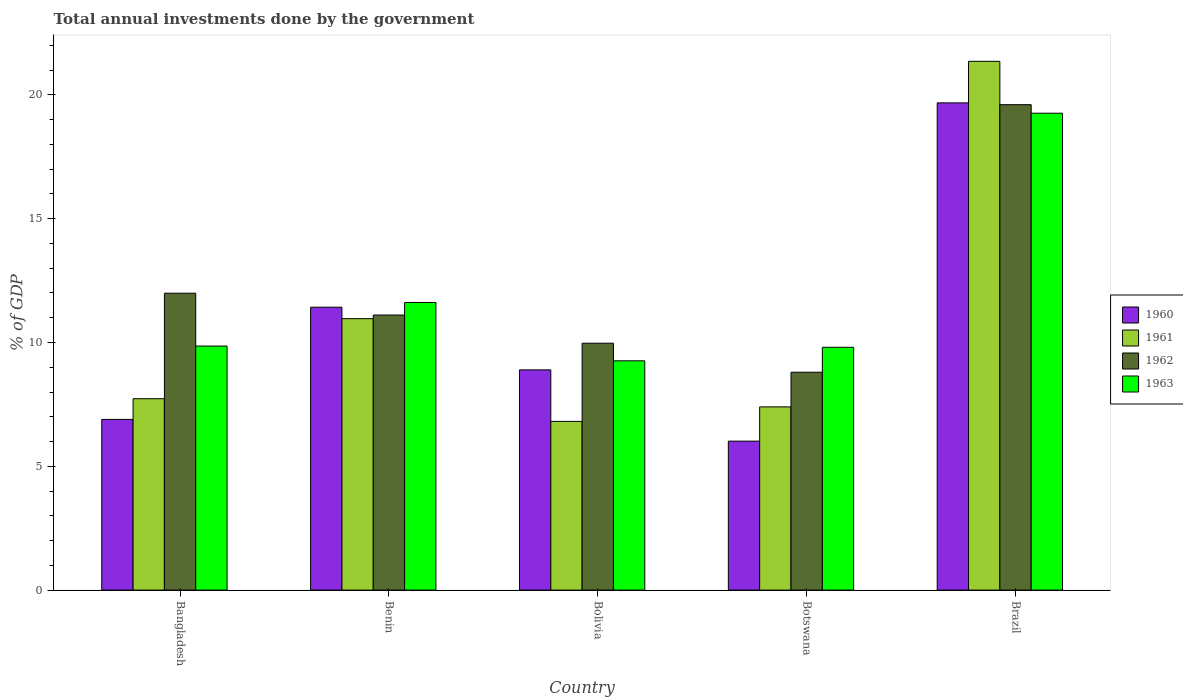How many different coloured bars are there?
Ensure brevity in your answer.  4. How many groups of bars are there?
Ensure brevity in your answer.  5. Are the number of bars on each tick of the X-axis equal?
Provide a succinct answer. Yes. How many bars are there on the 5th tick from the right?
Provide a succinct answer. 4. What is the label of the 5th group of bars from the left?
Your answer should be very brief. Brazil. What is the total annual investments done by the government in 1962 in Botswana?
Provide a succinct answer. 8.8. Across all countries, what is the maximum total annual investments done by the government in 1963?
Offer a very short reply. 19.26. Across all countries, what is the minimum total annual investments done by the government in 1961?
Keep it short and to the point. 6.81. In which country was the total annual investments done by the government in 1961 maximum?
Offer a terse response. Brazil. In which country was the total annual investments done by the government in 1962 minimum?
Your answer should be compact. Botswana. What is the total total annual investments done by the government in 1960 in the graph?
Offer a very short reply. 52.91. What is the difference between the total annual investments done by the government in 1960 in Bangladesh and that in Botswana?
Your answer should be compact. 0.88. What is the difference between the total annual investments done by the government in 1962 in Benin and the total annual investments done by the government in 1960 in Botswana?
Ensure brevity in your answer.  5.09. What is the average total annual investments done by the government in 1960 per country?
Provide a short and direct response. 10.58. What is the difference between the total annual investments done by the government of/in 1962 and total annual investments done by the government of/in 1960 in Bangladesh?
Provide a short and direct response. 5.1. In how many countries, is the total annual investments done by the government in 1960 greater than 17 %?
Your answer should be compact. 1. What is the ratio of the total annual investments done by the government in 1962 in Botswana to that in Brazil?
Provide a succinct answer. 0.45. Is the total annual investments done by the government in 1963 in Bangladesh less than that in Botswana?
Your response must be concise. No. Is the difference between the total annual investments done by the government in 1962 in Benin and Bolivia greater than the difference between the total annual investments done by the government in 1960 in Benin and Bolivia?
Keep it short and to the point. No. What is the difference between the highest and the second highest total annual investments done by the government in 1962?
Offer a very short reply. -7.61. What is the difference between the highest and the lowest total annual investments done by the government in 1963?
Give a very brief answer. 10. In how many countries, is the total annual investments done by the government in 1962 greater than the average total annual investments done by the government in 1962 taken over all countries?
Offer a very short reply. 1. Is the sum of the total annual investments done by the government in 1962 in Bolivia and Botswana greater than the maximum total annual investments done by the government in 1961 across all countries?
Keep it short and to the point. No. What does the 3rd bar from the right in Benin represents?
Your response must be concise. 1961. What is the difference between two consecutive major ticks on the Y-axis?
Your response must be concise. 5. Are the values on the major ticks of Y-axis written in scientific E-notation?
Make the answer very short. No. Does the graph contain grids?
Make the answer very short. No. Where does the legend appear in the graph?
Offer a terse response. Center right. How are the legend labels stacked?
Provide a short and direct response. Vertical. What is the title of the graph?
Ensure brevity in your answer.  Total annual investments done by the government. What is the label or title of the Y-axis?
Your response must be concise. % of GDP. What is the % of GDP of 1960 in Bangladesh?
Provide a succinct answer. 6.89. What is the % of GDP in 1961 in Bangladesh?
Ensure brevity in your answer.  7.73. What is the % of GDP in 1962 in Bangladesh?
Keep it short and to the point. 11.99. What is the % of GDP in 1963 in Bangladesh?
Offer a very short reply. 9.86. What is the % of GDP of 1960 in Benin?
Keep it short and to the point. 11.42. What is the % of GDP of 1961 in Benin?
Give a very brief answer. 10.96. What is the % of GDP of 1962 in Benin?
Make the answer very short. 11.11. What is the % of GDP of 1963 in Benin?
Your response must be concise. 11.62. What is the % of GDP in 1960 in Bolivia?
Your response must be concise. 8.89. What is the % of GDP in 1961 in Bolivia?
Keep it short and to the point. 6.81. What is the % of GDP of 1962 in Bolivia?
Give a very brief answer. 9.97. What is the % of GDP in 1963 in Bolivia?
Provide a succinct answer. 9.26. What is the % of GDP of 1960 in Botswana?
Keep it short and to the point. 6.02. What is the % of GDP in 1961 in Botswana?
Your answer should be compact. 7.4. What is the % of GDP in 1962 in Botswana?
Your response must be concise. 8.8. What is the % of GDP of 1963 in Botswana?
Keep it short and to the point. 9.81. What is the % of GDP in 1960 in Brazil?
Give a very brief answer. 19.68. What is the % of GDP of 1961 in Brazil?
Ensure brevity in your answer.  21.36. What is the % of GDP in 1962 in Brazil?
Offer a very short reply. 19.6. What is the % of GDP in 1963 in Brazil?
Your answer should be compact. 19.26. Across all countries, what is the maximum % of GDP of 1960?
Give a very brief answer. 19.68. Across all countries, what is the maximum % of GDP of 1961?
Provide a short and direct response. 21.36. Across all countries, what is the maximum % of GDP in 1962?
Offer a terse response. 19.6. Across all countries, what is the maximum % of GDP of 1963?
Your answer should be compact. 19.26. Across all countries, what is the minimum % of GDP of 1960?
Your answer should be very brief. 6.02. Across all countries, what is the minimum % of GDP in 1961?
Ensure brevity in your answer.  6.81. Across all countries, what is the minimum % of GDP of 1962?
Your response must be concise. 8.8. Across all countries, what is the minimum % of GDP of 1963?
Ensure brevity in your answer.  9.26. What is the total % of GDP in 1960 in the graph?
Ensure brevity in your answer.  52.91. What is the total % of GDP of 1961 in the graph?
Provide a succinct answer. 54.26. What is the total % of GDP in 1962 in the graph?
Give a very brief answer. 61.47. What is the total % of GDP of 1963 in the graph?
Keep it short and to the point. 59.8. What is the difference between the % of GDP in 1960 in Bangladesh and that in Benin?
Your answer should be compact. -4.53. What is the difference between the % of GDP of 1961 in Bangladesh and that in Benin?
Provide a short and direct response. -3.23. What is the difference between the % of GDP of 1962 in Bangladesh and that in Benin?
Your answer should be compact. 0.88. What is the difference between the % of GDP of 1963 in Bangladesh and that in Benin?
Offer a very short reply. -1.76. What is the difference between the % of GDP of 1961 in Bangladesh and that in Bolivia?
Provide a short and direct response. 0.92. What is the difference between the % of GDP of 1962 in Bangladesh and that in Bolivia?
Your response must be concise. 2.02. What is the difference between the % of GDP of 1963 in Bangladesh and that in Bolivia?
Make the answer very short. 0.6. What is the difference between the % of GDP in 1960 in Bangladesh and that in Botswana?
Give a very brief answer. 0.88. What is the difference between the % of GDP in 1961 in Bangladesh and that in Botswana?
Provide a succinct answer. 0.33. What is the difference between the % of GDP in 1962 in Bangladesh and that in Botswana?
Offer a terse response. 3.19. What is the difference between the % of GDP of 1963 in Bangladesh and that in Botswana?
Offer a terse response. 0.05. What is the difference between the % of GDP of 1960 in Bangladesh and that in Brazil?
Make the answer very short. -12.78. What is the difference between the % of GDP in 1961 in Bangladesh and that in Brazil?
Offer a terse response. -13.63. What is the difference between the % of GDP of 1962 in Bangladesh and that in Brazil?
Make the answer very short. -7.61. What is the difference between the % of GDP in 1963 in Bangladesh and that in Brazil?
Make the answer very short. -9.4. What is the difference between the % of GDP of 1960 in Benin and that in Bolivia?
Offer a very short reply. 2.53. What is the difference between the % of GDP in 1961 in Benin and that in Bolivia?
Provide a succinct answer. 4.15. What is the difference between the % of GDP of 1962 in Benin and that in Bolivia?
Give a very brief answer. 1.14. What is the difference between the % of GDP of 1963 in Benin and that in Bolivia?
Ensure brevity in your answer.  2.36. What is the difference between the % of GDP in 1960 in Benin and that in Botswana?
Give a very brief answer. 5.41. What is the difference between the % of GDP of 1961 in Benin and that in Botswana?
Keep it short and to the point. 3.56. What is the difference between the % of GDP in 1962 in Benin and that in Botswana?
Your answer should be compact. 2.31. What is the difference between the % of GDP of 1963 in Benin and that in Botswana?
Offer a very short reply. 1.81. What is the difference between the % of GDP of 1960 in Benin and that in Brazil?
Your response must be concise. -8.25. What is the difference between the % of GDP of 1961 in Benin and that in Brazil?
Give a very brief answer. -10.39. What is the difference between the % of GDP of 1962 in Benin and that in Brazil?
Offer a very short reply. -8.5. What is the difference between the % of GDP in 1963 in Benin and that in Brazil?
Make the answer very short. -7.64. What is the difference between the % of GDP in 1960 in Bolivia and that in Botswana?
Keep it short and to the point. 2.88. What is the difference between the % of GDP in 1961 in Bolivia and that in Botswana?
Provide a short and direct response. -0.59. What is the difference between the % of GDP in 1962 in Bolivia and that in Botswana?
Your response must be concise. 1.17. What is the difference between the % of GDP of 1963 in Bolivia and that in Botswana?
Your answer should be very brief. -0.55. What is the difference between the % of GDP of 1960 in Bolivia and that in Brazil?
Provide a short and direct response. -10.78. What is the difference between the % of GDP in 1961 in Bolivia and that in Brazil?
Provide a short and direct response. -14.54. What is the difference between the % of GDP of 1962 in Bolivia and that in Brazil?
Your answer should be compact. -9.63. What is the difference between the % of GDP of 1963 in Bolivia and that in Brazil?
Offer a very short reply. -10. What is the difference between the % of GDP of 1960 in Botswana and that in Brazil?
Ensure brevity in your answer.  -13.66. What is the difference between the % of GDP in 1961 in Botswana and that in Brazil?
Give a very brief answer. -13.96. What is the difference between the % of GDP in 1962 in Botswana and that in Brazil?
Your answer should be compact. -10.81. What is the difference between the % of GDP of 1963 in Botswana and that in Brazil?
Provide a succinct answer. -9.45. What is the difference between the % of GDP of 1960 in Bangladesh and the % of GDP of 1961 in Benin?
Your answer should be compact. -4.07. What is the difference between the % of GDP in 1960 in Bangladesh and the % of GDP in 1962 in Benin?
Offer a very short reply. -4.21. What is the difference between the % of GDP in 1960 in Bangladesh and the % of GDP in 1963 in Benin?
Make the answer very short. -4.72. What is the difference between the % of GDP of 1961 in Bangladesh and the % of GDP of 1962 in Benin?
Ensure brevity in your answer.  -3.38. What is the difference between the % of GDP of 1961 in Bangladesh and the % of GDP of 1963 in Benin?
Give a very brief answer. -3.89. What is the difference between the % of GDP of 1962 in Bangladesh and the % of GDP of 1963 in Benin?
Keep it short and to the point. 0.37. What is the difference between the % of GDP in 1960 in Bangladesh and the % of GDP in 1961 in Bolivia?
Offer a very short reply. 0.08. What is the difference between the % of GDP in 1960 in Bangladesh and the % of GDP in 1962 in Bolivia?
Ensure brevity in your answer.  -3.08. What is the difference between the % of GDP in 1960 in Bangladesh and the % of GDP in 1963 in Bolivia?
Offer a terse response. -2.37. What is the difference between the % of GDP in 1961 in Bangladesh and the % of GDP in 1962 in Bolivia?
Your answer should be compact. -2.24. What is the difference between the % of GDP in 1961 in Bangladesh and the % of GDP in 1963 in Bolivia?
Give a very brief answer. -1.53. What is the difference between the % of GDP in 1962 in Bangladesh and the % of GDP in 1963 in Bolivia?
Offer a very short reply. 2.73. What is the difference between the % of GDP of 1960 in Bangladesh and the % of GDP of 1961 in Botswana?
Ensure brevity in your answer.  -0.51. What is the difference between the % of GDP of 1960 in Bangladesh and the % of GDP of 1962 in Botswana?
Offer a terse response. -1.9. What is the difference between the % of GDP in 1960 in Bangladesh and the % of GDP in 1963 in Botswana?
Offer a very short reply. -2.91. What is the difference between the % of GDP in 1961 in Bangladesh and the % of GDP in 1962 in Botswana?
Your answer should be very brief. -1.07. What is the difference between the % of GDP in 1961 in Bangladesh and the % of GDP in 1963 in Botswana?
Your answer should be very brief. -2.08. What is the difference between the % of GDP in 1962 in Bangladesh and the % of GDP in 1963 in Botswana?
Your answer should be compact. 2.18. What is the difference between the % of GDP in 1960 in Bangladesh and the % of GDP in 1961 in Brazil?
Make the answer very short. -14.46. What is the difference between the % of GDP of 1960 in Bangladesh and the % of GDP of 1962 in Brazil?
Your answer should be very brief. -12.71. What is the difference between the % of GDP in 1960 in Bangladesh and the % of GDP in 1963 in Brazil?
Provide a short and direct response. -12.37. What is the difference between the % of GDP in 1961 in Bangladesh and the % of GDP in 1962 in Brazil?
Ensure brevity in your answer.  -11.88. What is the difference between the % of GDP of 1961 in Bangladesh and the % of GDP of 1963 in Brazil?
Make the answer very short. -11.53. What is the difference between the % of GDP of 1962 in Bangladesh and the % of GDP of 1963 in Brazil?
Offer a very short reply. -7.27. What is the difference between the % of GDP of 1960 in Benin and the % of GDP of 1961 in Bolivia?
Offer a terse response. 4.61. What is the difference between the % of GDP in 1960 in Benin and the % of GDP in 1962 in Bolivia?
Your answer should be very brief. 1.45. What is the difference between the % of GDP in 1960 in Benin and the % of GDP in 1963 in Bolivia?
Offer a terse response. 2.16. What is the difference between the % of GDP of 1961 in Benin and the % of GDP of 1963 in Bolivia?
Give a very brief answer. 1.7. What is the difference between the % of GDP of 1962 in Benin and the % of GDP of 1963 in Bolivia?
Provide a short and direct response. 1.85. What is the difference between the % of GDP in 1960 in Benin and the % of GDP in 1961 in Botswana?
Provide a succinct answer. 4.03. What is the difference between the % of GDP in 1960 in Benin and the % of GDP in 1962 in Botswana?
Provide a short and direct response. 2.63. What is the difference between the % of GDP in 1960 in Benin and the % of GDP in 1963 in Botswana?
Keep it short and to the point. 1.62. What is the difference between the % of GDP in 1961 in Benin and the % of GDP in 1962 in Botswana?
Give a very brief answer. 2.16. What is the difference between the % of GDP of 1961 in Benin and the % of GDP of 1963 in Botswana?
Keep it short and to the point. 1.16. What is the difference between the % of GDP of 1962 in Benin and the % of GDP of 1963 in Botswana?
Provide a succinct answer. 1.3. What is the difference between the % of GDP of 1960 in Benin and the % of GDP of 1961 in Brazil?
Keep it short and to the point. -9.93. What is the difference between the % of GDP of 1960 in Benin and the % of GDP of 1962 in Brazil?
Make the answer very short. -8.18. What is the difference between the % of GDP of 1960 in Benin and the % of GDP of 1963 in Brazil?
Ensure brevity in your answer.  -7.83. What is the difference between the % of GDP in 1961 in Benin and the % of GDP in 1962 in Brazil?
Your answer should be very brief. -8.64. What is the difference between the % of GDP of 1961 in Benin and the % of GDP of 1963 in Brazil?
Provide a short and direct response. -8.3. What is the difference between the % of GDP in 1962 in Benin and the % of GDP in 1963 in Brazil?
Your response must be concise. -8.15. What is the difference between the % of GDP in 1960 in Bolivia and the % of GDP in 1961 in Botswana?
Provide a short and direct response. 1.49. What is the difference between the % of GDP of 1960 in Bolivia and the % of GDP of 1962 in Botswana?
Provide a short and direct response. 0.1. What is the difference between the % of GDP of 1960 in Bolivia and the % of GDP of 1963 in Botswana?
Make the answer very short. -0.91. What is the difference between the % of GDP in 1961 in Bolivia and the % of GDP in 1962 in Botswana?
Your response must be concise. -1.99. What is the difference between the % of GDP of 1961 in Bolivia and the % of GDP of 1963 in Botswana?
Provide a succinct answer. -2.99. What is the difference between the % of GDP of 1962 in Bolivia and the % of GDP of 1963 in Botswana?
Provide a succinct answer. 0.16. What is the difference between the % of GDP in 1960 in Bolivia and the % of GDP in 1961 in Brazil?
Keep it short and to the point. -12.46. What is the difference between the % of GDP in 1960 in Bolivia and the % of GDP in 1962 in Brazil?
Provide a succinct answer. -10.71. What is the difference between the % of GDP of 1960 in Bolivia and the % of GDP of 1963 in Brazil?
Your answer should be compact. -10.37. What is the difference between the % of GDP of 1961 in Bolivia and the % of GDP of 1962 in Brazil?
Offer a terse response. -12.79. What is the difference between the % of GDP in 1961 in Bolivia and the % of GDP in 1963 in Brazil?
Your response must be concise. -12.45. What is the difference between the % of GDP in 1962 in Bolivia and the % of GDP in 1963 in Brazil?
Offer a very short reply. -9.29. What is the difference between the % of GDP in 1960 in Botswana and the % of GDP in 1961 in Brazil?
Make the answer very short. -15.34. What is the difference between the % of GDP in 1960 in Botswana and the % of GDP in 1962 in Brazil?
Provide a succinct answer. -13.59. What is the difference between the % of GDP in 1960 in Botswana and the % of GDP in 1963 in Brazil?
Your answer should be very brief. -13.24. What is the difference between the % of GDP of 1961 in Botswana and the % of GDP of 1962 in Brazil?
Offer a very short reply. -12.21. What is the difference between the % of GDP in 1961 in Botswana and the % of GDP in 1963 in Brazil?
Make the answer very short. -11.86. What is the difference between the % of GDP in 1962 in Botswana and the % of GDP in 1963 in Brazil?
Ensure brevity in your answer.  -10.46. What is the average % of GDP of 1960 per country?
Give a very brief answer. 10.58. What is the average % of GDP in 1961 per country?
Your response must be concise. 10.85. What is the average % of GDP in 1962 per country?
Your answer should be very brief. 12.29. What is the average % of GDP of 1963 per country?
Make the answer very short. 11.96. What is the difference between the % of GDP in 1960 and % of GDP in 1961 in Bangladesh?
Keep it short and to the point. -0.84. What is the difference between the % of GDP of 1960 and % of GDP of 1962 in Bangladesh?
Your answer should be very brief. -5.1. What is the difference between the % of GDP of 1960 and % of GDP of 1963 in Bangladesh?
Give a very brief answer. -2.96. What is the difference between the % of GDP in 1961 and % of GDP in 1962 in Bangladesh?
Keep it short and to the point. -4.26. What is the difference between the % of GDP in 1961 and % of GDP in 1963 in Bangladesh?
Your answer should be very brief. -2.13. What is the difference between the % of GDP of 1962 and % of GDP of 1963 in Bangladesh?
Give a very brief answer. 2.13. What is the difference between the % of GDP in 1960 and % of GDP in 1961 in Benin?
Your answer should be compact. 0.46. What is the difference between the % of GDP in 1960 and % of GDP in 1962 in Benin?
Keep it short and to the point. 0.32. What is the difference between the % of GDP in 1960 and % of GDP in 1963 in Benin?
Your answer should be very brief. -0.19. What is the difference between the % of GDP of 1961 and % of GDP of 1962 in Benin?
Provide a succinct answer. -0.15. What is the difference between the % of GDP of 1961 and % of GDP of 1963 in Benin?
Keep it short and to the point. -0.65. What is the difference between the % of GDP of 1962 and % of GDP of 1963 in Benin?
Offer a very short reply. -0.51. What is the difference between the % of GDP of 1960 and % of GDP of 1961 in Bolivia?
Offer a terse response. 2.08. What is the difference between the % of GDP of 1960 and % of GDP of 1962 in Bolivia?
Your response must be concise. -1.08. What is the difference between the % of GDP of 1960 and % of GDP of 1963 in Bolivia?
Offer a very short reply. -0.37. What is the difference between the % of GDP in 1961 and % of GDP in 1962 in Bolivia?
Make the answer very short. -3.16. What is the difference between the % of GDP in 1961 and % of GDP in 1963 in Bolivia?
Ensure brevity in your answer.  -2.45. What is the difference between the % of GDP of 1962 and % of GDP of 1963 in Bolivia?
Your answer should be very brief. 0.71. What is the difference between the % of GDP in 1960 and % of GDP in 1961 in Botswana?
Give a very brief answer. -1.38. What is the difference between the % of GDP of 1960 and % of GDP of 1962 in Botswana?
Make the answer very short. -2.78. What is the difference between the % of GDP in 1960 and % of GDP in 1963 in Botswana?
Your answer should be very brief. -3.79. What is the difference between the % of GDP of 1961 and % of GDP of 1962 in Botswana?
Your answer should be compact. -1.4. What is the difference between the % of GDP in 1961 and % of GDP in 1963 in Botswana?
Give a very brief answer. -2.41. What is the difference between the % of GDP in 1962 and % of GDP in 1963 in Botswana?
Ensure brevity in your answer.  -1.01. What is the difference between the % of GDP in 1960 and % of GDP in 1961 in Brazil?
Provide a short and direct response. -1.68. What is the difference between the % of GDP of 1960 and % of GDP of 1962 in Brazil?
Offer a terse response. 0.07. What is the difference between the % of GDP of 1960 and % of GDP of 1963 in Brazil?
Provide a succinct answer. 0.42. What is the difference between the % of GDP in 1961 and % of GDP in 1962 in Brazil?
Offer a terse response. 1.75. What is the difference between the % of GDP of 1961 and % of GDP of 1963 in Brazil?
Give a very brief answer. 2.1. What is the difference between the % of GDP of 1962 and % of GDP of 1963 in Brazil?
Your answer should be very brief. 0.34. What is the ratio of the % of GDP in 1960 in Bangladesh to that in Benin?
Give a very brief answer. 0.6. What is the ratio of the % of GDP of 1961 in Bangladesh to that in Benin?
Provide a short and direct response. 0.71. What is the ratio of the % of GDP of 1962 in Bangladesh to that in Benin?
Your response must be concise. 1.08. What is the ratio of the % of GDP of 1963 in Bangladesh to that in Benin?
Provide a short and direct response. 0.85. What is the ratio of the % of GDP in 1960 in Bangladesh to that in Bolivia?
Give a very brief answer. 0.78. What is the ratio of the % of GDP of 1961 in Bangladesh to that in Bolivia?
Your answer should be very brief. 1.13. What is the ratio of the % of GDP in 1962 in Bangladesh to that in Bolivia?
Your answer should be compact. 1.2. What is the ratio of the % of GDP of 1963 in Bangladesh to that in Bolivia?
Make the answer very short. 1.06. What is the ratio of the % of GDP of 1960 in Bangladesh to that in Botswana?
Provide a short and direct response. 1.15. What is the ratio of the % of GDP of 1961 in Bangladesh to that in Botswana?
Make the answer very short. 1.04. What is the ratio of the % of GDP in 1962 in Bangladesh to that in Botswana?
Your response must be concise. 1.36. What is the ratio of the % of GDP of 1960 in Bangladesh to that in Brazil?
Offer a terse response. 0.35. What is the ratio of the % of GDP in 1961 in Bangladesh to that in Brazil?
Provide a succinct answer. 0.36. What is the ratio of the % of GDP of 1962 in Bangladesh to that in Brazil?
Ensure brevity in your answer.  0.61. What is the ratio of the % of GDP in 1963 in Bangladesh to that in Brazil?
Offer a very short reply. 0.51. What is the ratio of the % of GDP in 1960 in Benin to that in Bolivia?
Provide a succinct answer. 1.28. What is the ratio of the % of GDP of 1961 in Benin to that in Bolivia?
Ensure brevity in your answer.  1.61. What is the ratio of the % of GDP of 1962 in Benin to that in Bolivia?
Your answer should be very brief. 1.11. What is the ratio of the % of GDP in 1963 in Benin to that in Bolivia?
Your answer should be very brief. 1.25. What is the ratio of the % of GDP of 1960 in Benin to that in Botswana?
Your answer should be compact. 1.9. What is the ratio of the % of GDP of 1961 in Benin to that in Botswana?
Provide a short and direct response. 1.48. What is the ratio of the % of GDP in 1962 in Benin to that in Botswana?
Ensure brevity in your answer.  1.26. What is the ratio of the % of GDP in 1963 in Benin to that in Botswana?
Your answer should be compact. 1.18. What is the ratio of the % of GDP in 1960 in Benin to that in Brazil?
Offer a terse response. 0.58. What is the ratio of the % of GDP of 1961 in Benin to that in Brazil?
Give a very brief answer. 0.51. What is the ratio of the % of GDP in 1962 in Benin to that in Brazil?
Keep it short and to the point. 0.57. What is the ratio of the % of GDP in 1963 in Benin to that in Brazil?
Give a very brief answer. 0.6. What is the ratio of the % of GDP of 1960 in Bolivia to that in Botswana?
Offer a very short reply. 1.48. What is the ratio of the % of GDP of 1961 in Bolivia to that in Botswana?
Give a very brief answer. 0.92. What is the ratio of the % of GDP in 1962 in Bolivia to that in Botswana?
Give a very brief answer. 1.13. What is the ratio of the % of GDP of 1963 in Bolivia to that in Botswana?
Your response must be concise. 0.94. What is the ratio of the % of GDP of 1960 in Bolivia to that in Brazil?
Your answer should be compact. 0.45. What is the ratio of the % of GDP of 1961 in Bolivia to that in Brazil?
Provide a succinct answer. 0.32. What is the ratio of the % of GDP in 1962 in Bolivia to that in Brazil?
Make the answer very short. 0.51. What is the ratio of the % of GDP in 1963 in Bolivia to that in Brazil?
Offer a very short reply. 0.48. What is the ratio of the % of GDP of 1960 in Botswana to that in Brazil?
Make the answer very short. 0.31. What is the ratio of the % of GDP of 1961 in Botswana to that in Brazil?
Keep it short and to the point. 0.35. What is the ratio of the % of GDP in 1962 in Botswana to that in Brazil?
Give a very brief answer. 0.45. What is the ratio of the % of GDP in 1963 in Botswana to that in Brazil?
Your answer should be very brief. 0.51. What is the difference between the highest and the second highest % of GDP in 1960?
Offer a very short reply. 8.25. What is the difference between the highest and the second highest % of GDP in 1961?
Offer a very short reply. 10.39. What is the difference between the highest and the second highest % of GDP of 1962?
Give a very brief answer. 7.61. What is the difference between the highest and the second highest % of GDP of 1963?
Your answer should be compact. 7.64. What is the difference between the highest and the lowest % of GDP in 1960?
Ensure brevity in your answer.  13.66. What is the difference between the highest and the lowest % of GDP of 1961?
Make the answer very short. 14.54. What is the difference between the highest and the lowest % of GDP in 1962?
Your response must be concise. 10.81. What is the difference between the highest and the lowest % of GDP of 1963?
Your response must be concise. 10. 